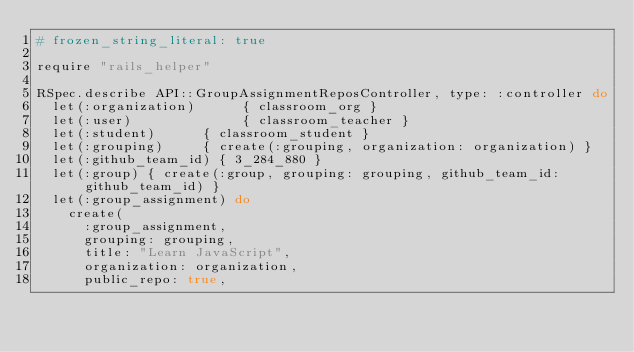<code> <loc_0><loc_0><loc_500><loc_500><_Ruby_># frozen_string_literal: true

require "rails_helper"

RSpec.describe API::GroupAssignmentReposController, type: :controller do
  let(:organization)      { classroom_org }
  let(:user)              { classroom_teacher }
  let(:student)      { classroom_student }
  let(:grouping)     { create(:grouping, organization: organization) }
  let(:github_team_id) { 3_284_880 }
  let(:group) { create(:group, grouping: grouping, github_team_id: github_team_id) }
  let(:group_assignment) do
    create(
      :group_assignment,
      grouping: grouping,
      title: "Learn JavaScript",
      organization: organization,
      public_repo: true,</code> 